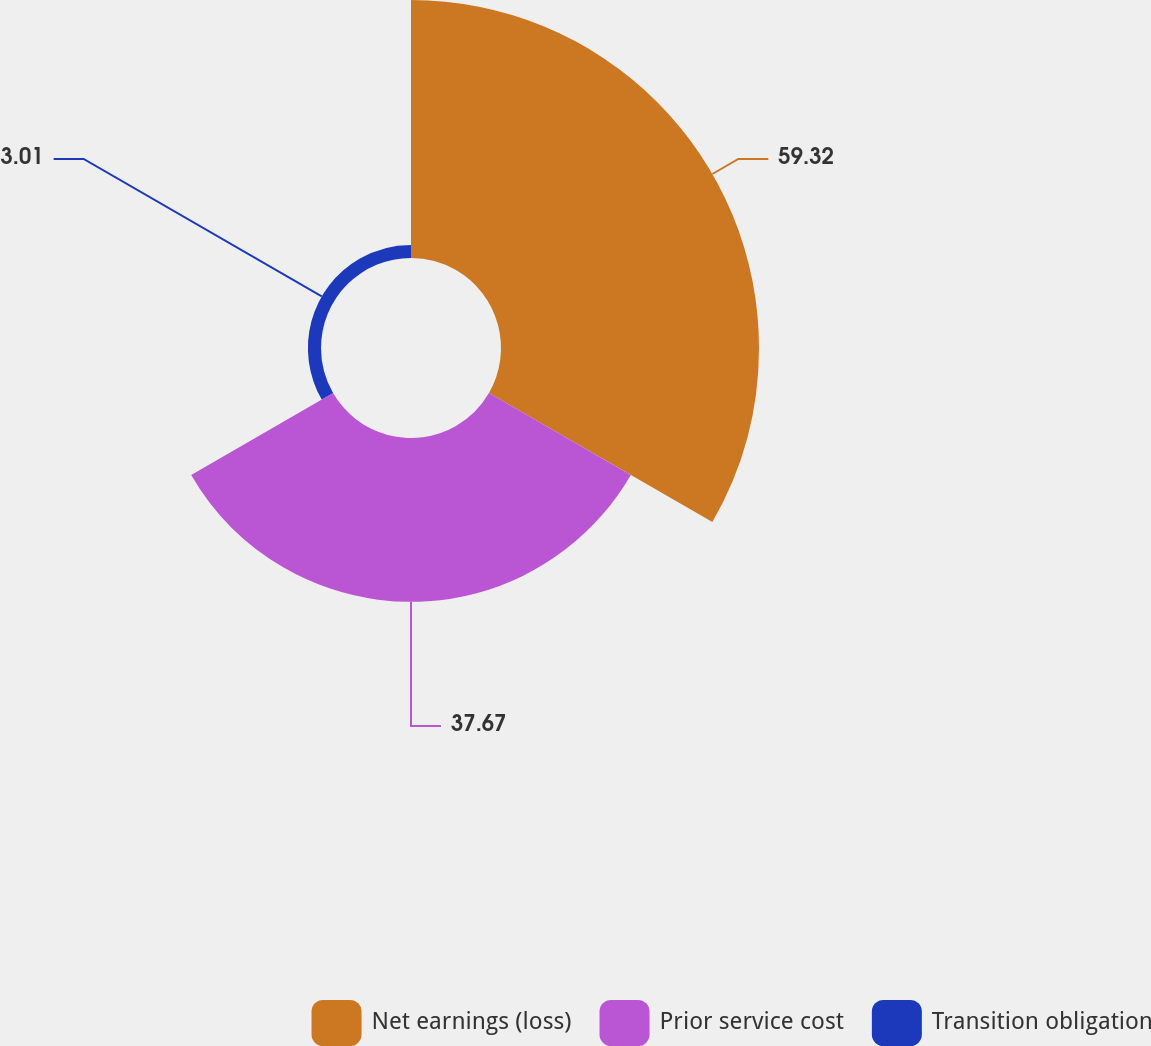Convert chart. <chart><loc_0><loc_0><loc_500><loc_500><pie_chart><fcel>Net earnings (loss)<fcel>Prior service cost<fcel>Transition obligation<nl><fcel>59.33%<fcel>37.67%<fcel>3.01%<nl></chart> 